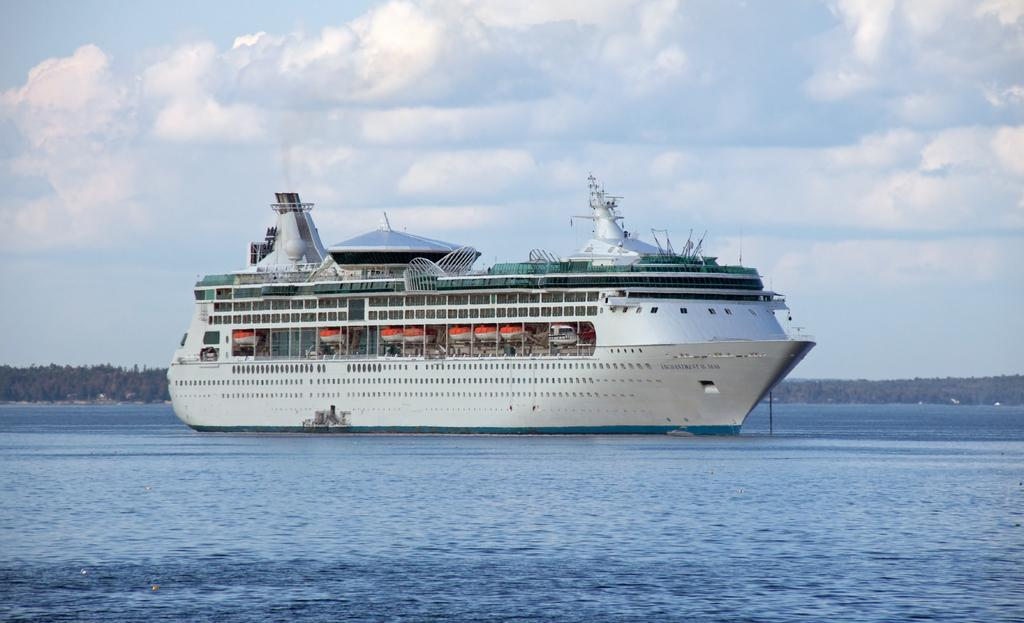What is the main subject in the middle of the image? There is a boat in the middle of the image. What can be seen at the bottom of the image? Waves and water are visible at the bottom of the image. What type of vegetation is in the background of the image? There are trees in the background of the image. What is visible in the sky in the background of the image? The sky is visible in the background of the image, and clouds are present. What activity are the eyes of the boat engaged in within the image? There are no eyes present on the boat in the image, as boats do not have eyes or engage in activities. 